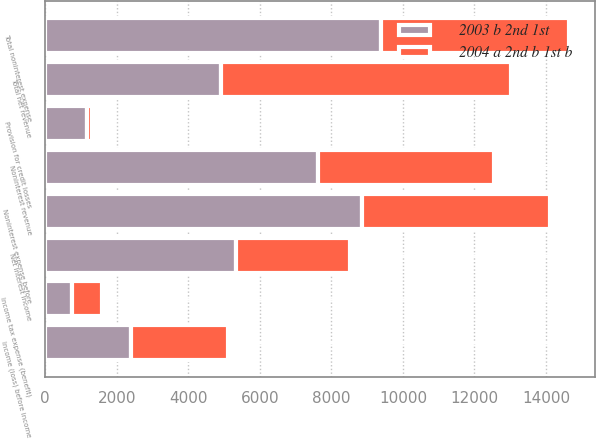Convert chart. <chart><loc_0><loc_0><loc_500><loc_500><stacked_bar_chart><ecel><fcel>Net interest income<fcel>Noninterest revenue<fcel>Total net revenue<fcel>Provision for credit losses<fcel>Noninterest expense before<fcel>Total noninterest expense<fcel>Income (loss) before income<fcel>Income tax expense (benefit)<nl><fcel>2003 b 2nd 1st<fcel>5329<fcel>7621<fcel>4924<fcel>1157<fcel>8863<fcel>9386<fcel>2407<fcel>741<nl><fcel>2004 a 2nd b 1st b<fcel>3182<fcel>4924<fcel>8106<fcel>139<fcel>5258<fcel>5258<fcel>2709<fcel>845<nl></chart> 